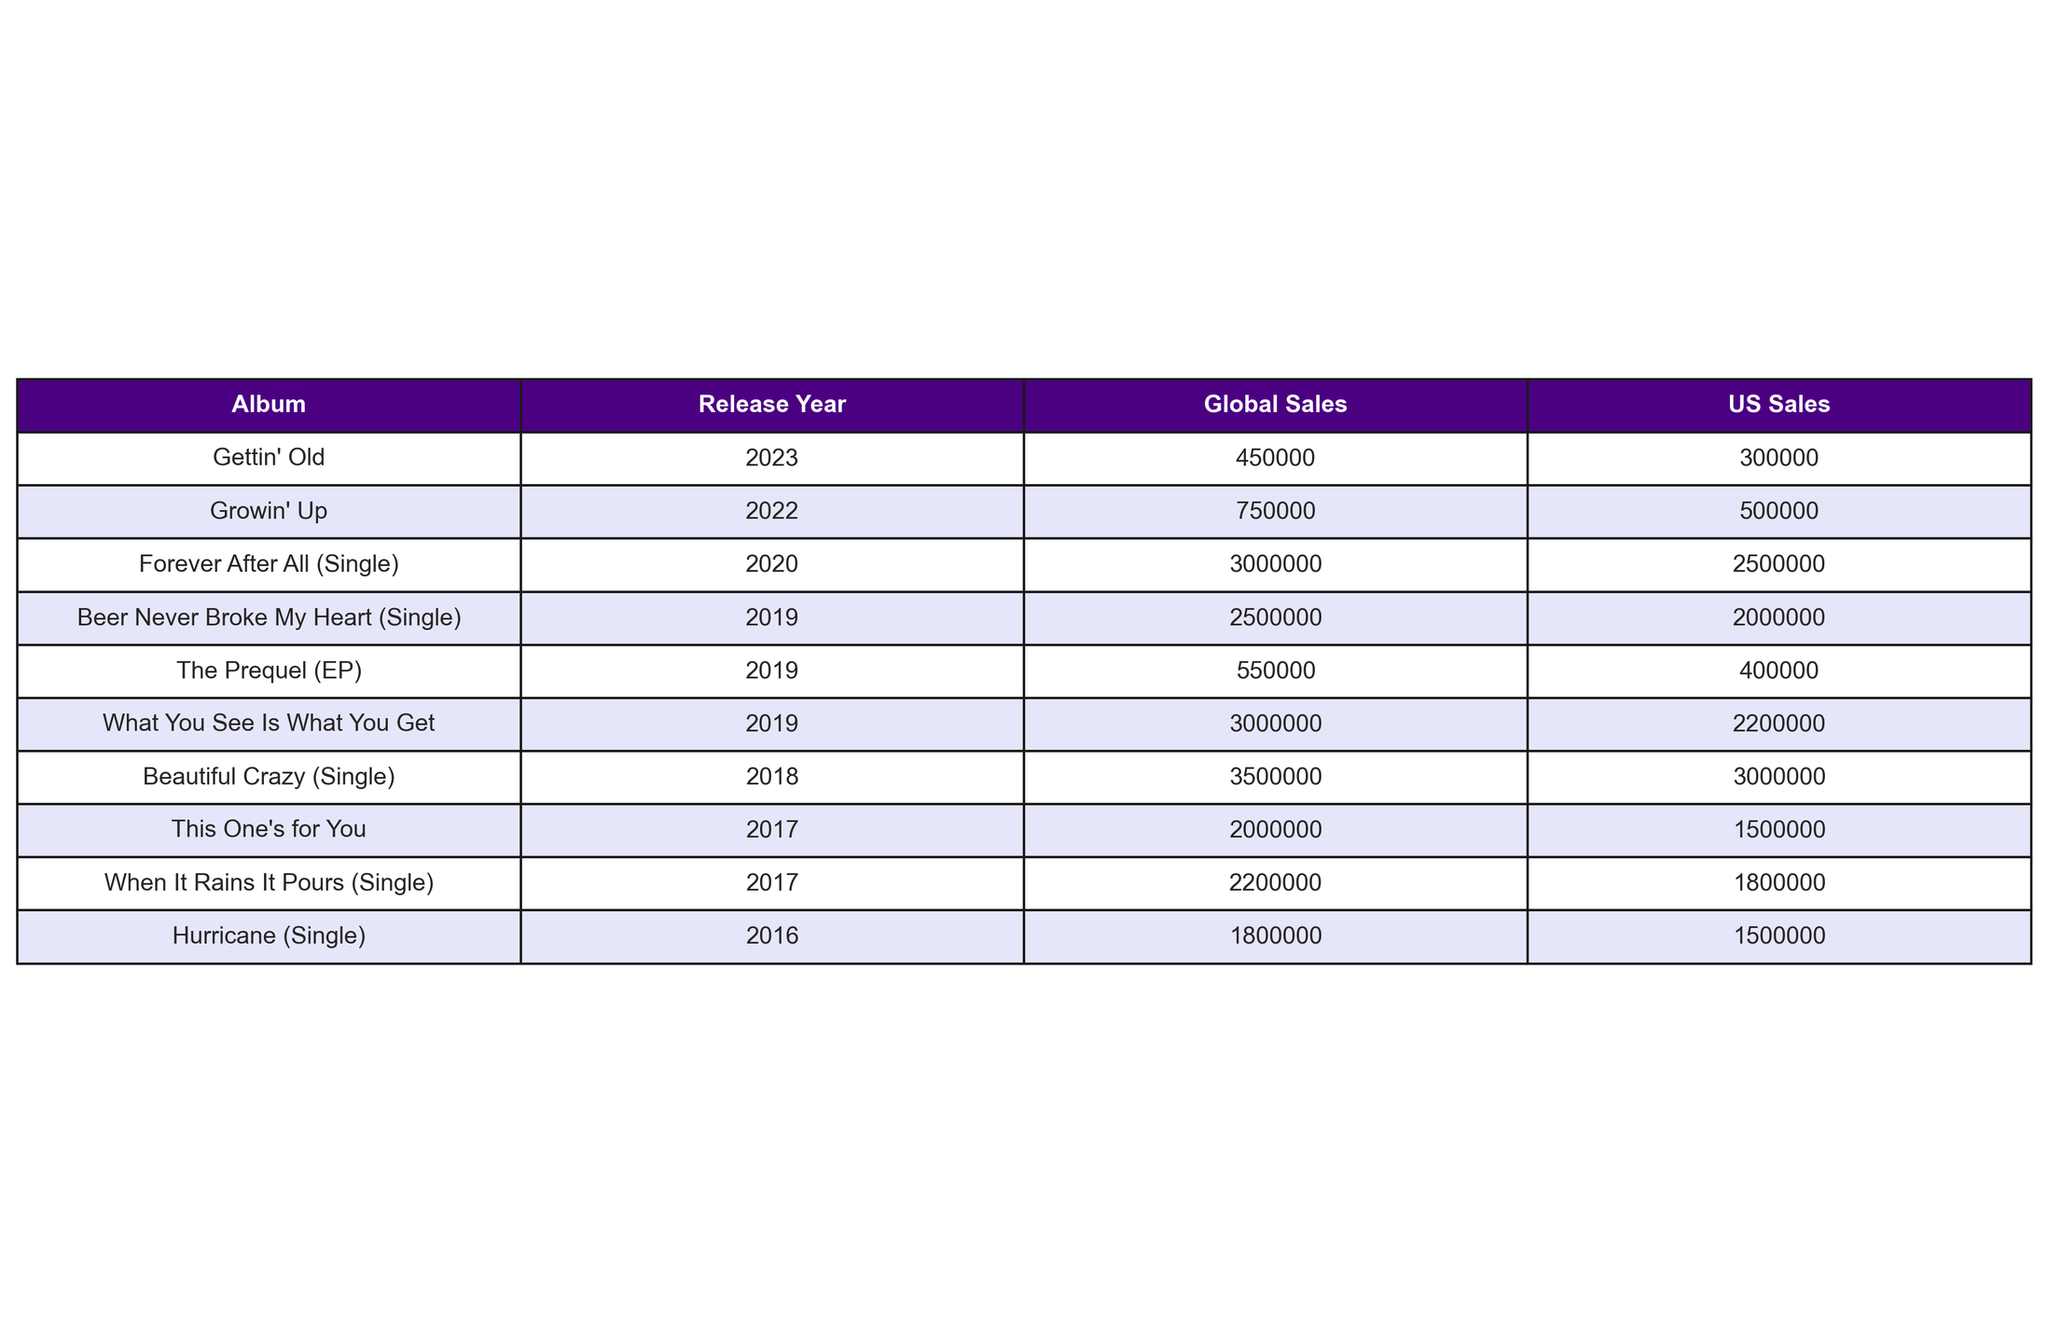What is the total US sales of Luke Combs' albums up to 2023? To find the total US sales, I need to sum the US Sales figures of all listed albums: 1500000 + 2200000 + 500000 + 300000 + 400000 + 2000000 + 3000000 + 2500000 + 1800000 + 1500000 = 15700000.
Answer: 15700000 Which album has the highest global sales? By inspecting the global sales column, the album "Beautiful Crazy" has the highest figure at 3500000.
Answer: 3500000 Did "Growin' Up" surpass 1 million in US sales? The US sales figure for "Growin' Up" is 500000, which is less than 1 million.
Answer: No What is the difference in US sales between "What You See Is What You Get" and "This One's for You"? The US sales for "What You See Is What You Get" is 2200000 and for "This One's for You" is 1500000. The difference is 2200000 - 1500000 = 700000.
Answer: 700000 How many albums were released in 2019? From the release year column, I can count the albums released in 2019: "What You See Is What You Get," "The Prequel (EP)," and "Beer Never Broke My Heart." Therefore, there are 3 albums.
Answer: 3 What is the average global sales of all albums released before 2020? To find this, I need to sum the global sales of albums before 2020: 2000000 (This One's for You) + 3000000 (What You See Is What You Get) + 3500000 (Beautiful Crazy) + 2200000 (When It Rains It Pours) + 1800000 (Hurricane) + 550000 (The Prequel) = 10700000. There are 6 albums, so the average global sales is 10700000 / 6 ≈ 1783333.33.
Answer: 1783333.33 Is the total US sales of singles greater than the US sales of albums? The total US sales for singles (2000000 + 3000000 + 2500000 + 1800000 + 1500000) sums to 10800000. The total US sales for all albums is 15700000. Since 10800000 < 15700000, the statement is false.
Answer: No What is the median global sales of Luke Combs' albums? To find the median, I list the global sales figures: 2000000, 3000000, 750000, 450000, 550000, 2500000, 3500000, 3000000, 2200000, 1800000. Sorting these gives: 450000, 550000, 750000, 2000000, 2200000, 2500000, 3000000, 3000000, 3500000. With 10 data points, the median is the average of the 5th and 6th: (2200000 + 2500000) / 2 = 2350000.
Answer: 2350000 